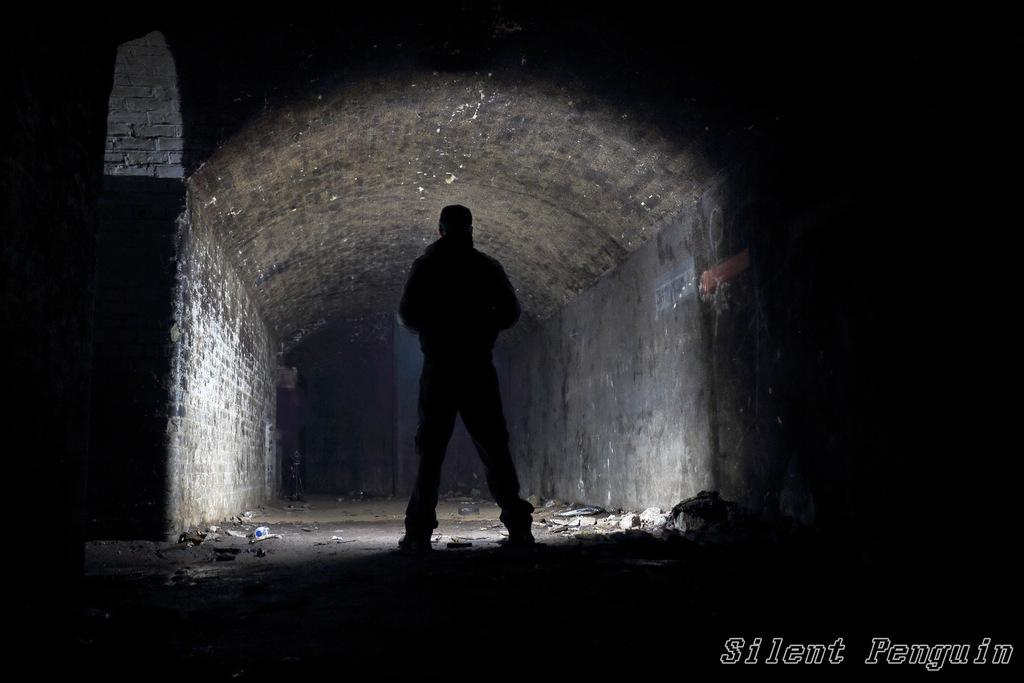What is the main subject of the image? There is a person in the image. Can you describe the person's location in the image? The person is standing in between walls. What type of attraction can be seen in the image? There is no attraction present in the image; it features a person standing in between walls. How many ants are visible on the person's bed in the image? There is no bed present in the image, so it is not possible to determine if there are any ants on it. 